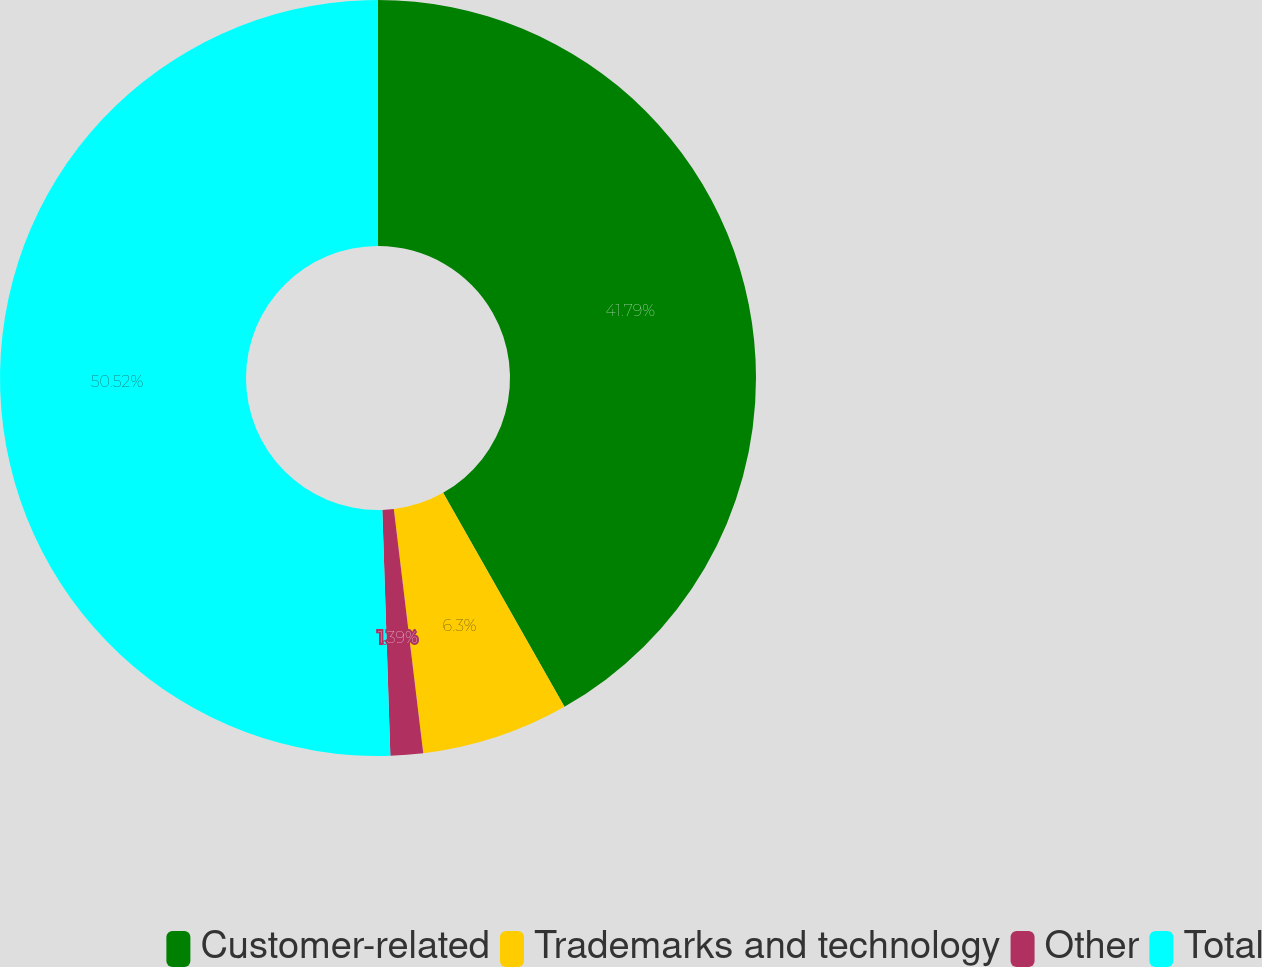<chart> <loc_0><loc_0><loc_500><loc_500><pie_chart><fcel>Customer-related<fcel>Trademarks and technology<fcel>Other<fcel>Total<nl><fcel>41.79%<fcel>6.3%<fcel>1.39%<fcel>50.52%<nl></chart> 